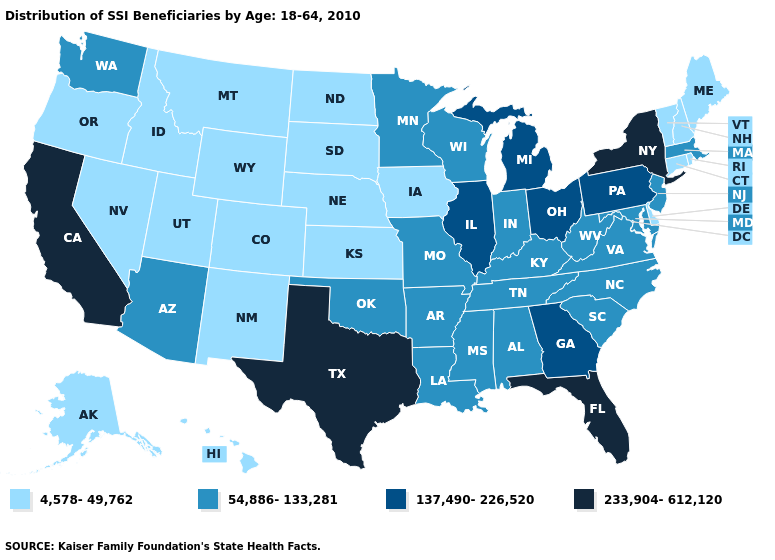Name the states that have a value in the range 137,490-226,520?
Give a very brief answer. Georgia, Illinois, Michigan, Ohio, Pennsylvania. What is the value of Rhode Island?
Concise answer only. 4,578-49,762. What is the value of Maine?
Answer briefly. 4,578-49,762. Name the states that have a value in the range 54,886-133,281?
Keep it brief. Alabama, Arizona, Arkansas, Indiana, Kentucky, Louisiana, Maryland, Massachusetts, Minnesota, Mississippi, Missouri, New Jersey, North Carolina, Oklahoma, South Carolina, Tennessee, Virginia, Washington, West Virginia, Wisconsin. What is the value of Mississippi?
Concise answer only. 54,886-133,281. What is the highest value in the MidWest ?
Give a very brief answer. 137,490-226,520. Among the states that border Florida , does Georgia have the highest value?
Answer briefly. Yes. Does the first symbol in the legend represent the smallest category?
Concise answer only. Yes. Name the states that have a value in the range 233,904-612,120?
Give a very brief answer. California, Florida, New York, Texas. Among the states that border Arizona , does Colorado have the lowest value?
Concise answer only. Yes. Does Delaware have the lowest value in the South?
Concise answer only. Yes. Name the states that have a value in the range 137,490-226,520?
Keep it brief. Georgia, Illinois, Michigan, Ohio, Pennsylvania. Among the states that border North Carolina , which have the highest value?
Concise answer only. Georgia. What is the value of Pennsylvania?
Quick response, please. 137,490-226,520. Among the states that border South Dakota , which have the highest value?
Be succinct. Minnesota. 